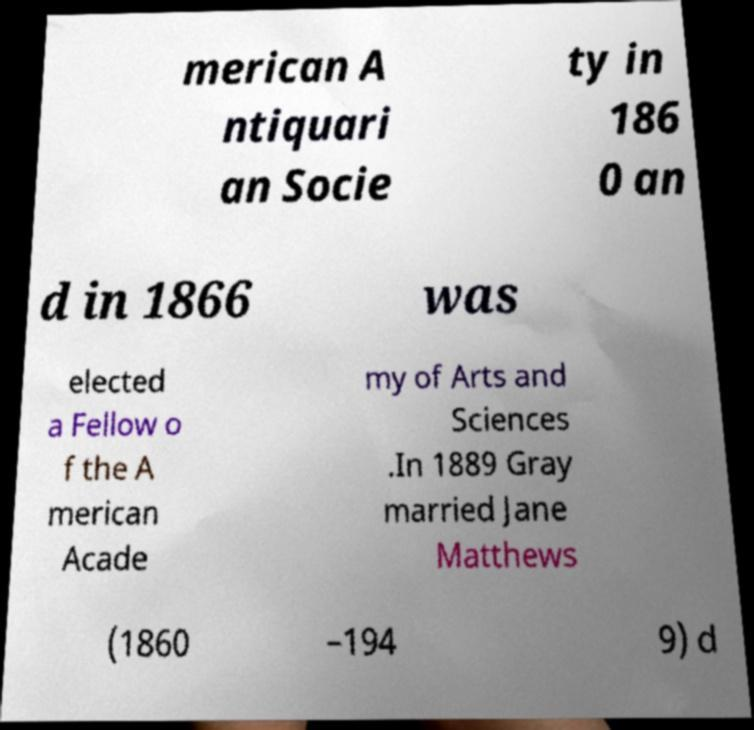Can you read and provide the text displayed in the image?This photo seems to have some interesting text. Can you extract and type it out for me? merican A ntiquari an Socie ty in 186 0 an d in 1866 was elected a Fellow o f the A merican Acade my of Arts and Sciences .In 1889 Gray married Jane Matthews (1860 –194 9) d 